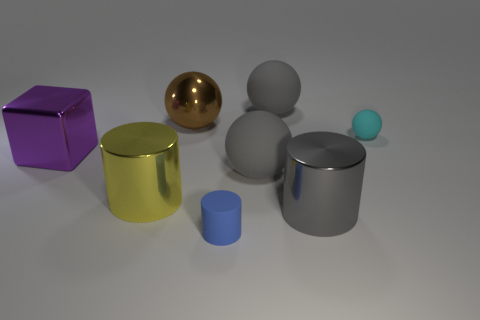Subtract all large brown metal balls. How many balls are left? 3 Subtract all purple cubes. How many gray balls are left? 2 Subtract all cyan spheres. How many spheres are left? 3 Subtract all brown cylinders. Subtract all brown spheres. How many cylinders are left? 3 Add 1 gray metal things. How many objects exist? 9 Subtract all cylinders. How many objects are left? 5 Subtract all large green spheres. Subtract all large brown balls. How many objects are left? 7 Add 6 small cylinders. How many small cylinders are left? 7 Add 1 large purple metallic cubes. How many large purple metallic cubes exist? 2 Subtract 1 blue cylinders. How many objects are left? 7 